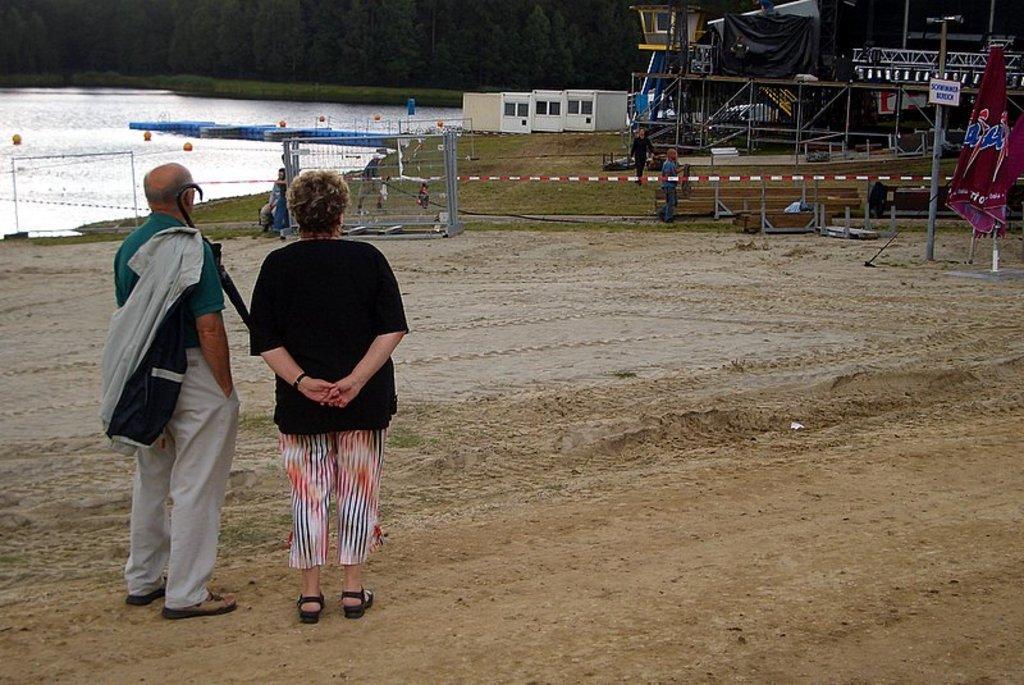Can you describe this image briefly? Here we can see a small lake and we can see a open land. Here we can see two people who are standing and she is women and he is men who is holding a jacket and umbrella in his hand and they are few people who are working and also i can see electrical pole and they are three sheds after that we can see trees. Finally we can find red and white color pole which is fixed and attached to the another pole. 